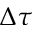<formula> <loc_0><loc_0><loc_500><loc_500>\Delta \tau</formula> 